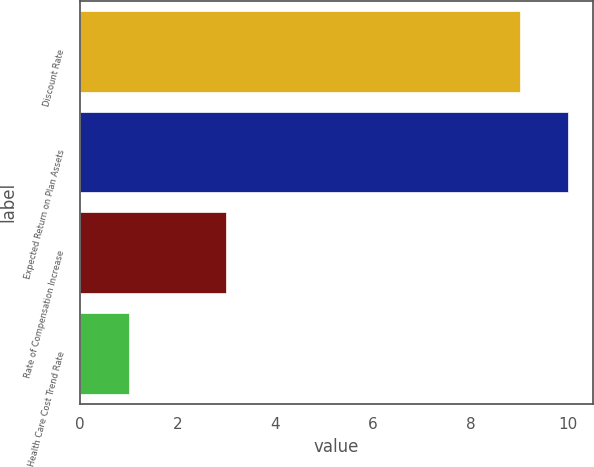Convert chart. <chart><loc_0><loc_0><loc_500><loc_500><bar_chart><fcel>Discount Rate<fcel>Expected Return on Plan Assets<fcel>Rate of Compensation Increase<fcel>Health Care Cost Trend Rate<nl><fcel>9<fcel>10<fcel>3<fcel>1<nl></chart> 